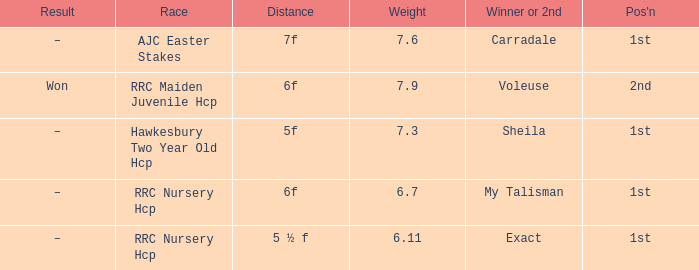What is the the name of the winner or 2nd  with a weight more than 7.3, and the result was –? Carradale. 